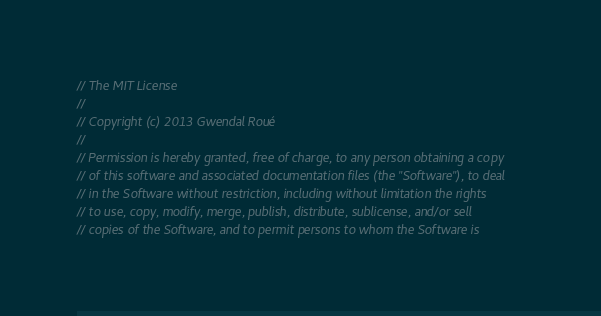Convert code to text. <code><loc_0><loc_0><loc_500><loc_500><_C_>// The MIT License
// 
// Copyright (c) 2013 Gwendal Roué
// 
// Permission is hereby granted, free of charge, to any person obtaining a copy
// of this software and associated documentation files (the "Software"), to deal
// in the Software without restriction, including without limitation the rights
// to use, copy, modify, merge, publish, distribute, sublicense, and/or sell
// copies of the Software, and to permit persons to whom the Software is</code> 